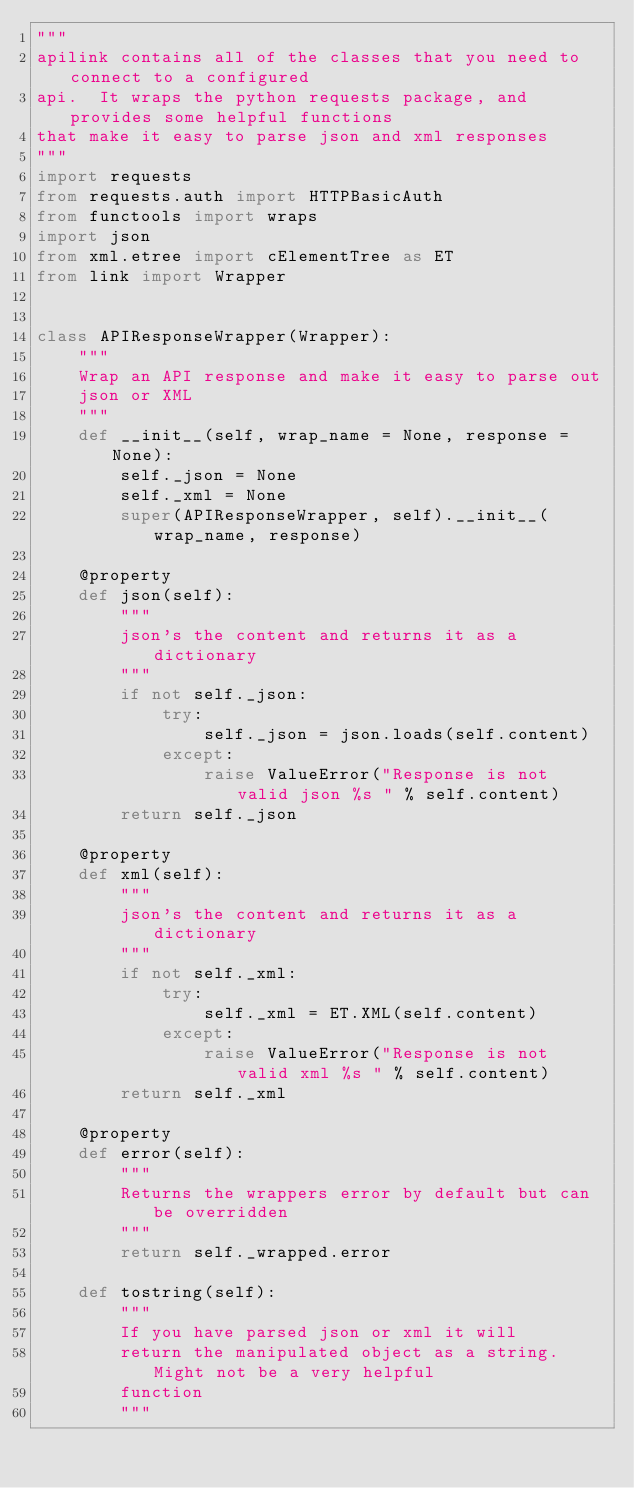Convert code to text. <code><loc_0><loc_0><loc_500><loc_500><_Python_>"""
apilink contains all of the classes that you need to connect to a configured
api.  It wraps the python requests package, and provides some helpful functions
that make it easy to parse json and xml responses
"""
import requests
from requests.auth import HTTPBasicAuth
from functools import wraps
import json
from xml.etree import cElementTree as ET
from link import Wrapper


class APIResponseWrapper(Wrapper):
    """
    Wrap an API response and make it easy to parse out
    json or XML
    """
    def __init__(self, wrap_name = None, response = None):
        self._json = None
        self._xml = None
        super(APIResponseWrapper, self).__init__(wrap_name, response)

    @property
    def json(self):
        """
        json's the content and returns it as a dictionary
        """
        if not self._json:
            try:
                self._json = json.loads(self.content)
            except:
                raise ValueError("Response is not valid json %s " % self.content)
        return self._json

    @property
    def xml(self):
        """
        json's the content and returns it as a dictionary
        """
        if not self._xml:
            try:
                self._xml = ET.XML(self.content)
            except:
                raise ValueError("Response is not valid xml %s " % self.content)
        return self._xml

    @property
    def error(self):
        """
        Returns the wrappers error by default but can be overridden 
        """
        return self._wrapped.error
 
    def tostring(self):
        """
        If you have parsed json or xml it will
        return the manipulated object as a string.  Might not be a very helpful
        function
        """</code> 